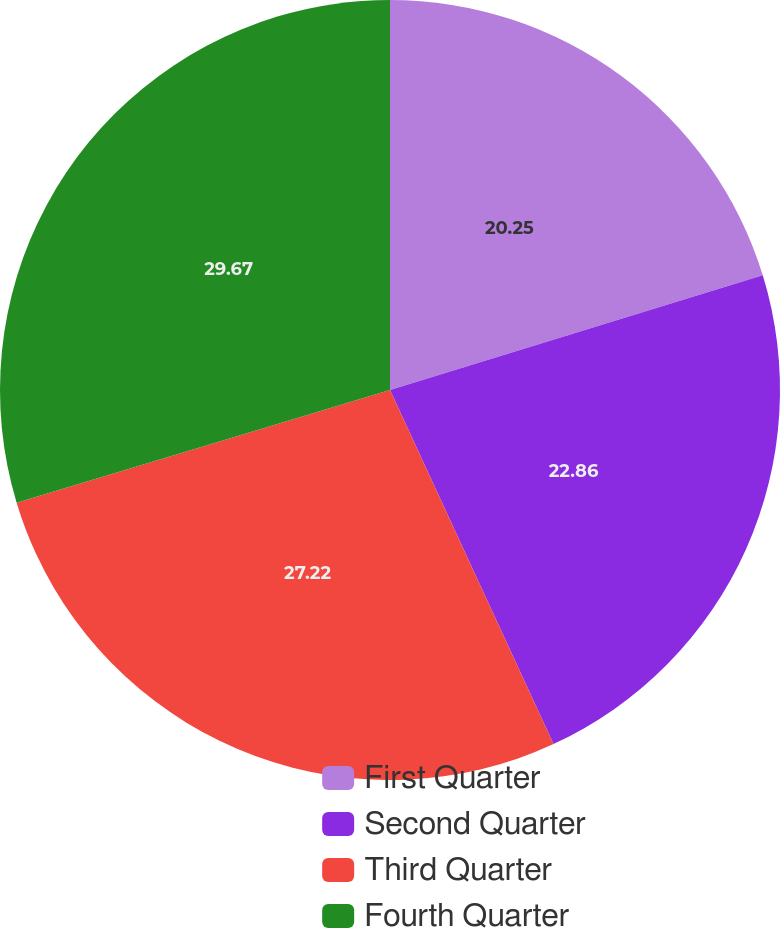Convert chart to OTSL. <chart><loc_0><loc_0><loc_500><loc_500><pie_chart><fcel>First Quarter<fcel>Second Quarter<fcel>Third Quarter<fcel>Fourth Quarter<nl><fcel>20.25%<fcel>22.86%<fcel>27.22%<fcel>29.66%<nl></chart> 